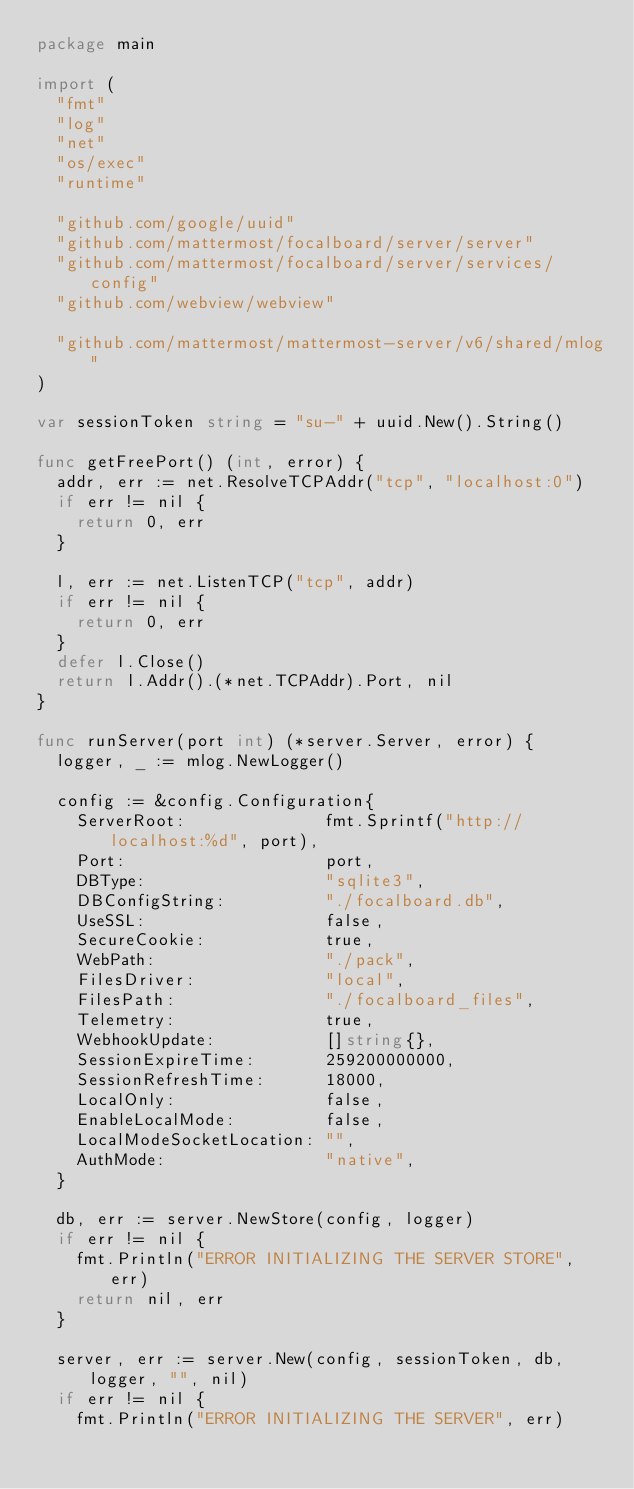Convert code to text. <code><loc_0><loc_0><loc_500><loc_500><_Go_>package main

import (
	"fmt"
	"log"
	"net"
	"os/exec"
	"runtime"

	"github.com/google/uuid"
	"github.com/mattermost/focalboard/server/server"
	"github.com/mattermost/focalboard/server/services/config"
	"github.com/webview/webview"

	"github.com/mattermost/mattermost-server/v6/shared/mlog"
)

var sessionToken string = "su-" + uuid.New().String()

func getFreePort() (int, error) {
	addr, err := net.ResolveTCPAddr("tcp", "localhost:0")
	if err != nil {
		return 0, err
	}

	l, err := net.ListenTCP("tcp", addr)
	if err != nil {
		return 0, err
	}
	defer l.Close()
	return l.Addr().(*net.TCPAddr).Port, nil
}

func runServer(port int) (*server.Server, error) {
	logger, _ := mlog.NewLogger()

	config := &config.Configuration{
		ServerRoot:              fmt.Sprintf("http://localhost:%d", port),
		Port:                    port,
		DBType:                  "sqlite3",
		DBConfigString:          "./focalboard.db",
		UseSSL:                  false,
		SecureCookie:            true,
		WebPath:                 "./pack",
		FilesDriver:             "local",
		FilesPath:               "./focalboard_files",
		Telemetry:               true,
		WebhookUpdate:           []string{},
		SessionExpireTime:       259200000000,
		SessionRefreshTime:      18000,
		LocalOnly:               false,
		EnableLocalMode:         false,
		LocalModeSocketLocation: "",
		AuthMode:                "native",
	}

	db, err := server.NewStore(config, logger)
	if err != nil {
		fmt.Println("ERROR INITIALIZING THE SERVER STORE", err)
		return nil, err
	}

	server, err := server.New(config, sessionToken, db, logger, "", nil)
	if err != nil {
		fmt.Println("ERROR INITIALIZING THE SERVER", err)</code> 